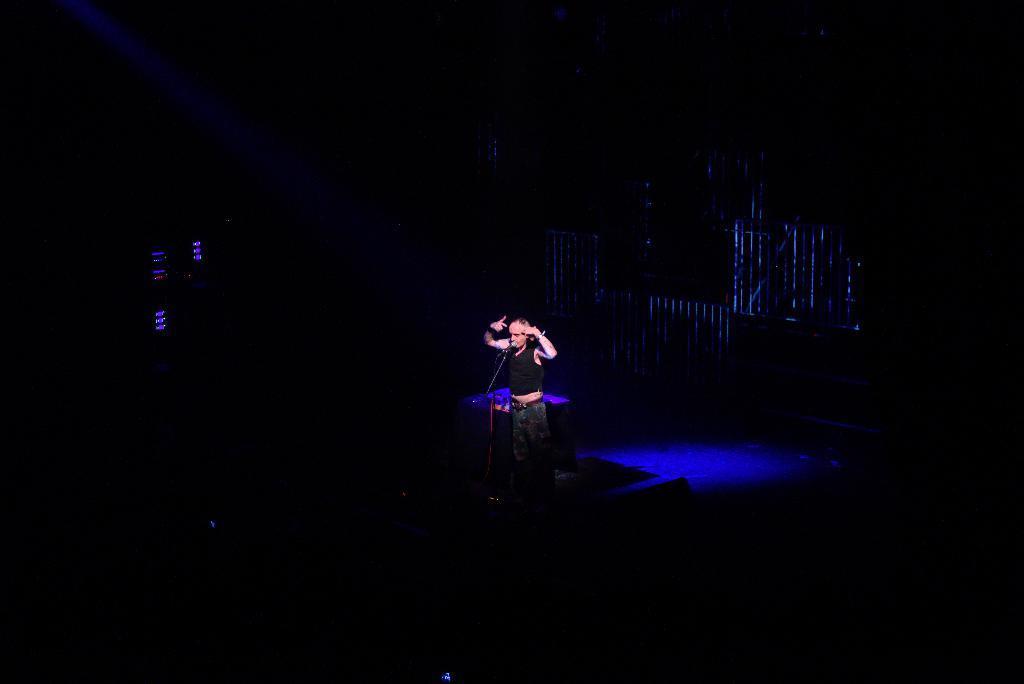In one or two sentences, can you explain what this image depicts? In this picture we can observe a person standing in front of a mic and stand. We can observe blue color light behind the person. The background is completely dark. 